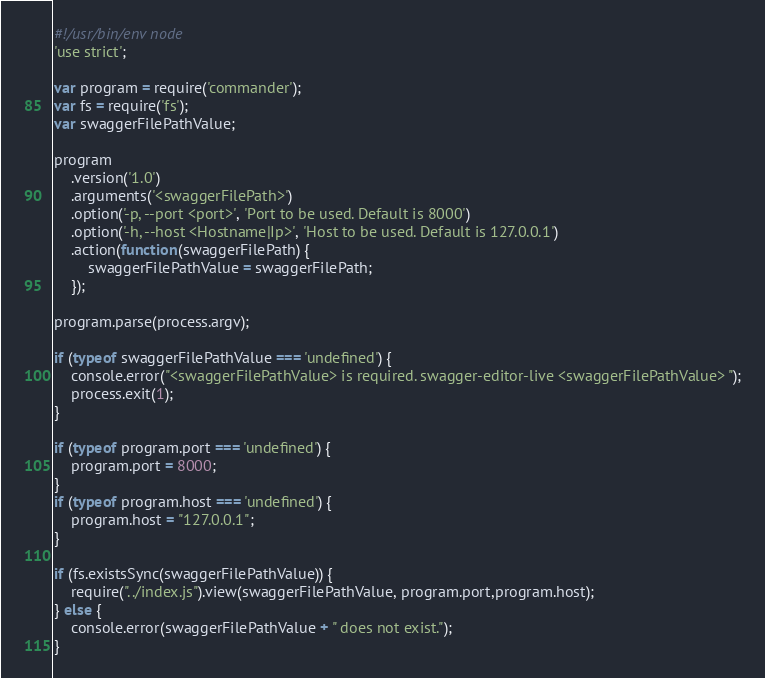Convert code to text. <code><loc_0><loc_0><loc_500><loc_500><_JavaScript_>#!/usr/bin/env node
'use strict';

var program = require('commander');
var fs = require('fs');
var swaggerFilePathValue;

program
    .version('1.0')
    .arguments('<swaggerFilePath>')
    .option('-p, --port <port>', 'Port to be used. Default is 8000')
    .option('-h, --host <Hostname|Ip>', 'Host to be used. Default is 127.0.0.1')
    .action(function(swaggerFilePath) {
        swaggerFilePathValue = swaggerFilePath;
    });

program.parse(process.argv);

if (typeof swaggerFilePathValue === 'undefined') {
    console.error("<swaggerFilePathValue> is required. swagger-editor-live <swaggerFilePathValue> ");
    process.exit(1);
}

if (typeof program.port === 'undefined') {
    program.port = 8000;
}
if (typeof program.host === 'undefined') {
    program.host = "127.0.0.1";
}

if (fs.existsSync(swaggerFilePathValue)) {
    require("../index.js").view(swaggerFilePathValue, program.port,program.host);
} else {
    console.error(swaggerFilePathValue + " does not exist.");
}</code> 